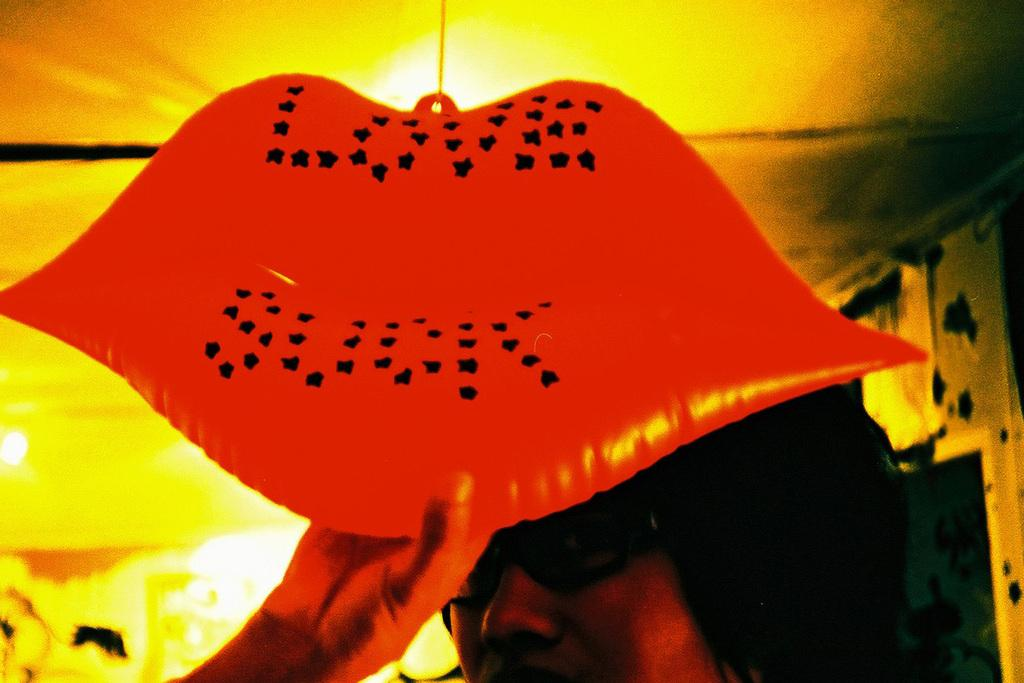Who is present in the image? There is a woman in the image. What is the woman wearing on her face? The woman is wearing spectacles. What is the woman holding in the image? The woman is holding an object. Can you describe the background of the image? The background of the image is blurred. What can be seen in the background of the image besides the blurred area? There are lights visible in the background of the image. What type of pie is the woman eating in the image? There is no pie present in the image; the woman is holding an object. How many fingers is the woman using to hold the object in the image? The number of fingers the woman is using to hold the object cannot be determined from the image. 